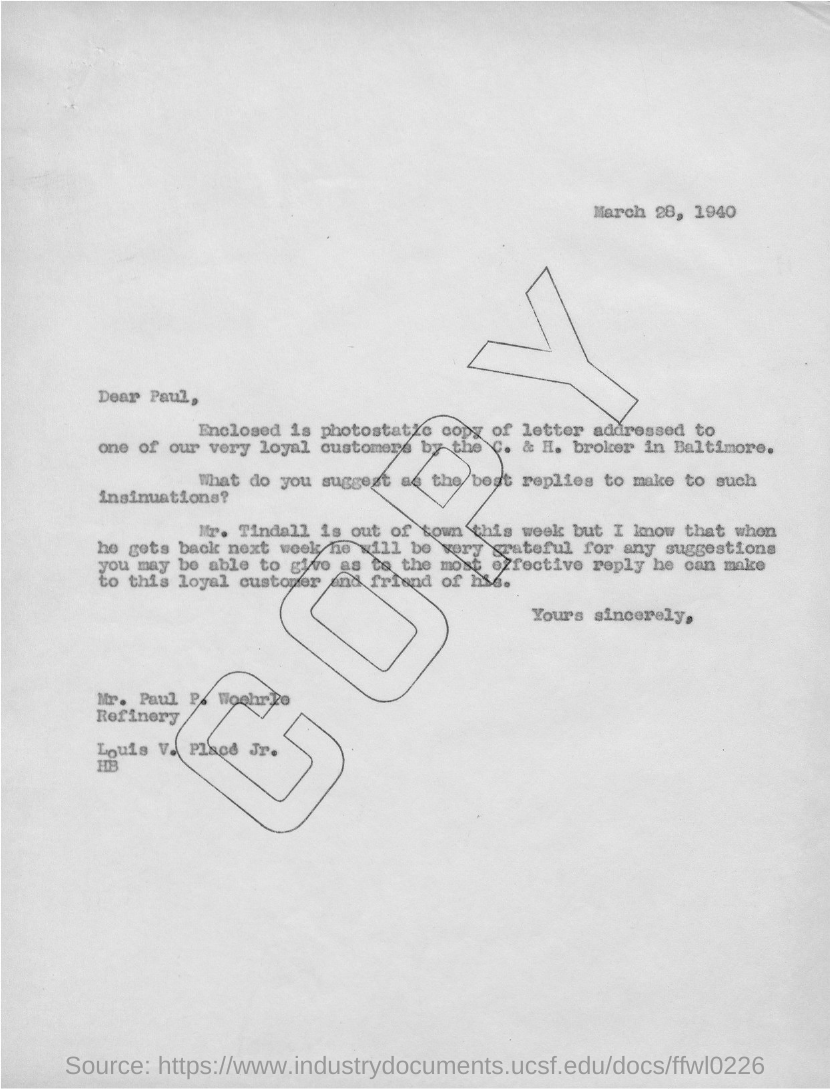Give some essential details in this illustration. The date mentioned in this letter is March 28, 1940. 